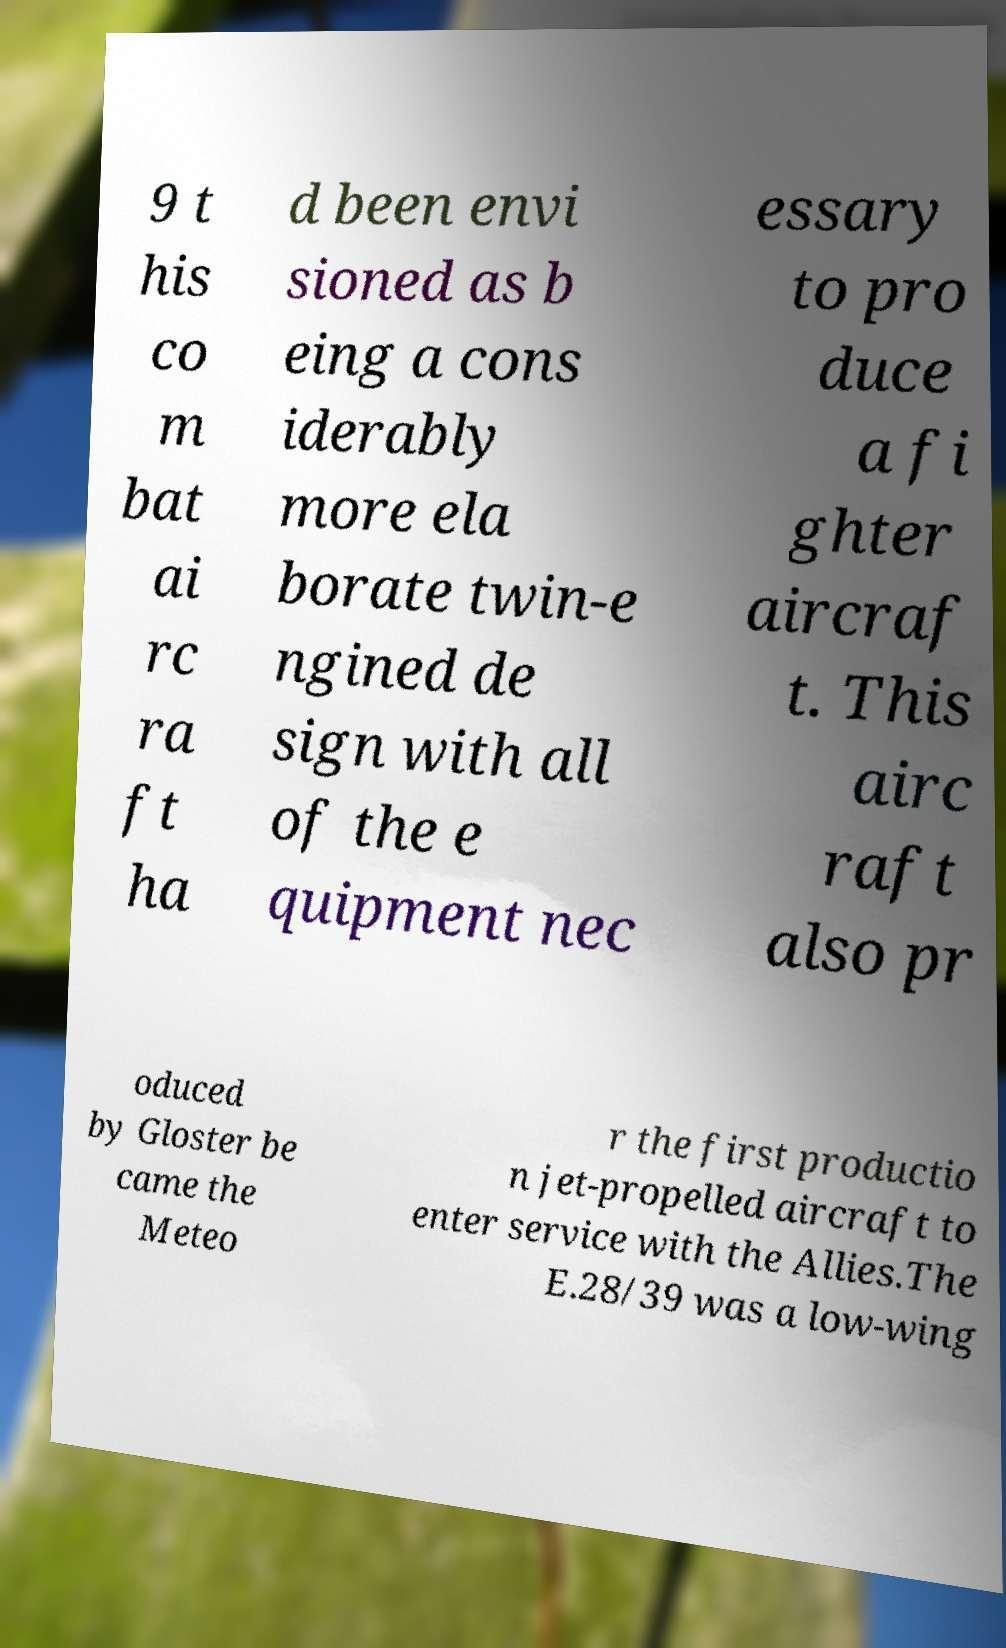Please identify and transcribe the text found in this image. 9 t his co m bat ai rc ra ft ha d been envi sioned as b eing a cons iderably more ela borate twin-e ngined de sign with all of the e quipment nec essary to pro duce a fi ghter aircraf t. This airc raft also pr oduced by Gloster be came the Meteo r the first productio n jet-propelled aircraft to enter service with the Allies.The E.28/39 was a low-wing 